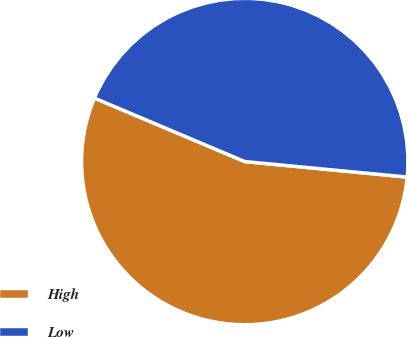Convert chart. <chart><loc_0><loc_0><loc_500><loc_500><pie_chart><fcel>High<fcel>Low<nl><fcel>54.84%<fcel>45.16%<nl></chart> 